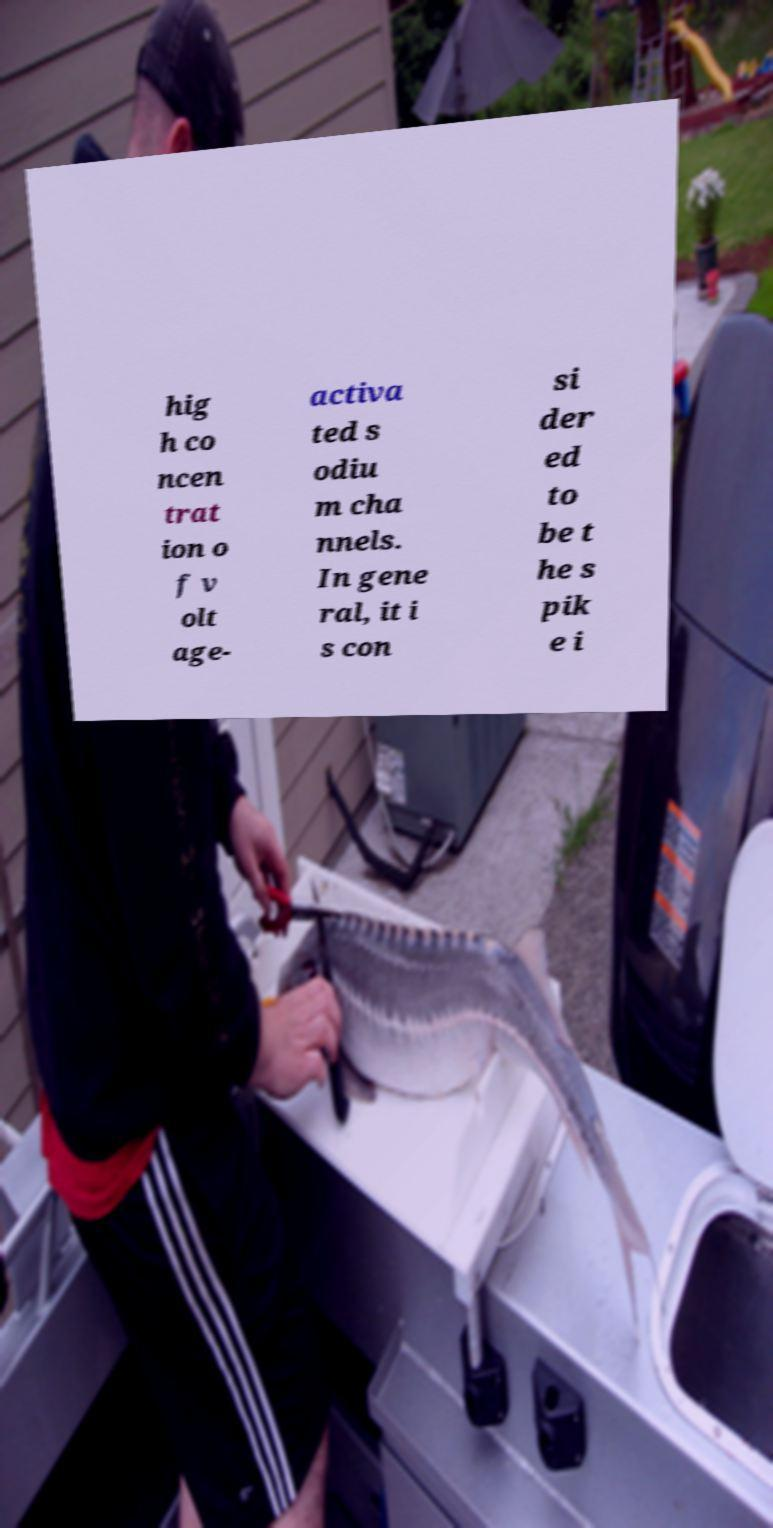There's text embedded in this image that I need extracted. Can you transcribe it verbatim? hig h co ncen trat ion o f v olt age- activa ted s odiu m cha nnels. In gene ral, it i s con si der ed to be t he s pik e i 